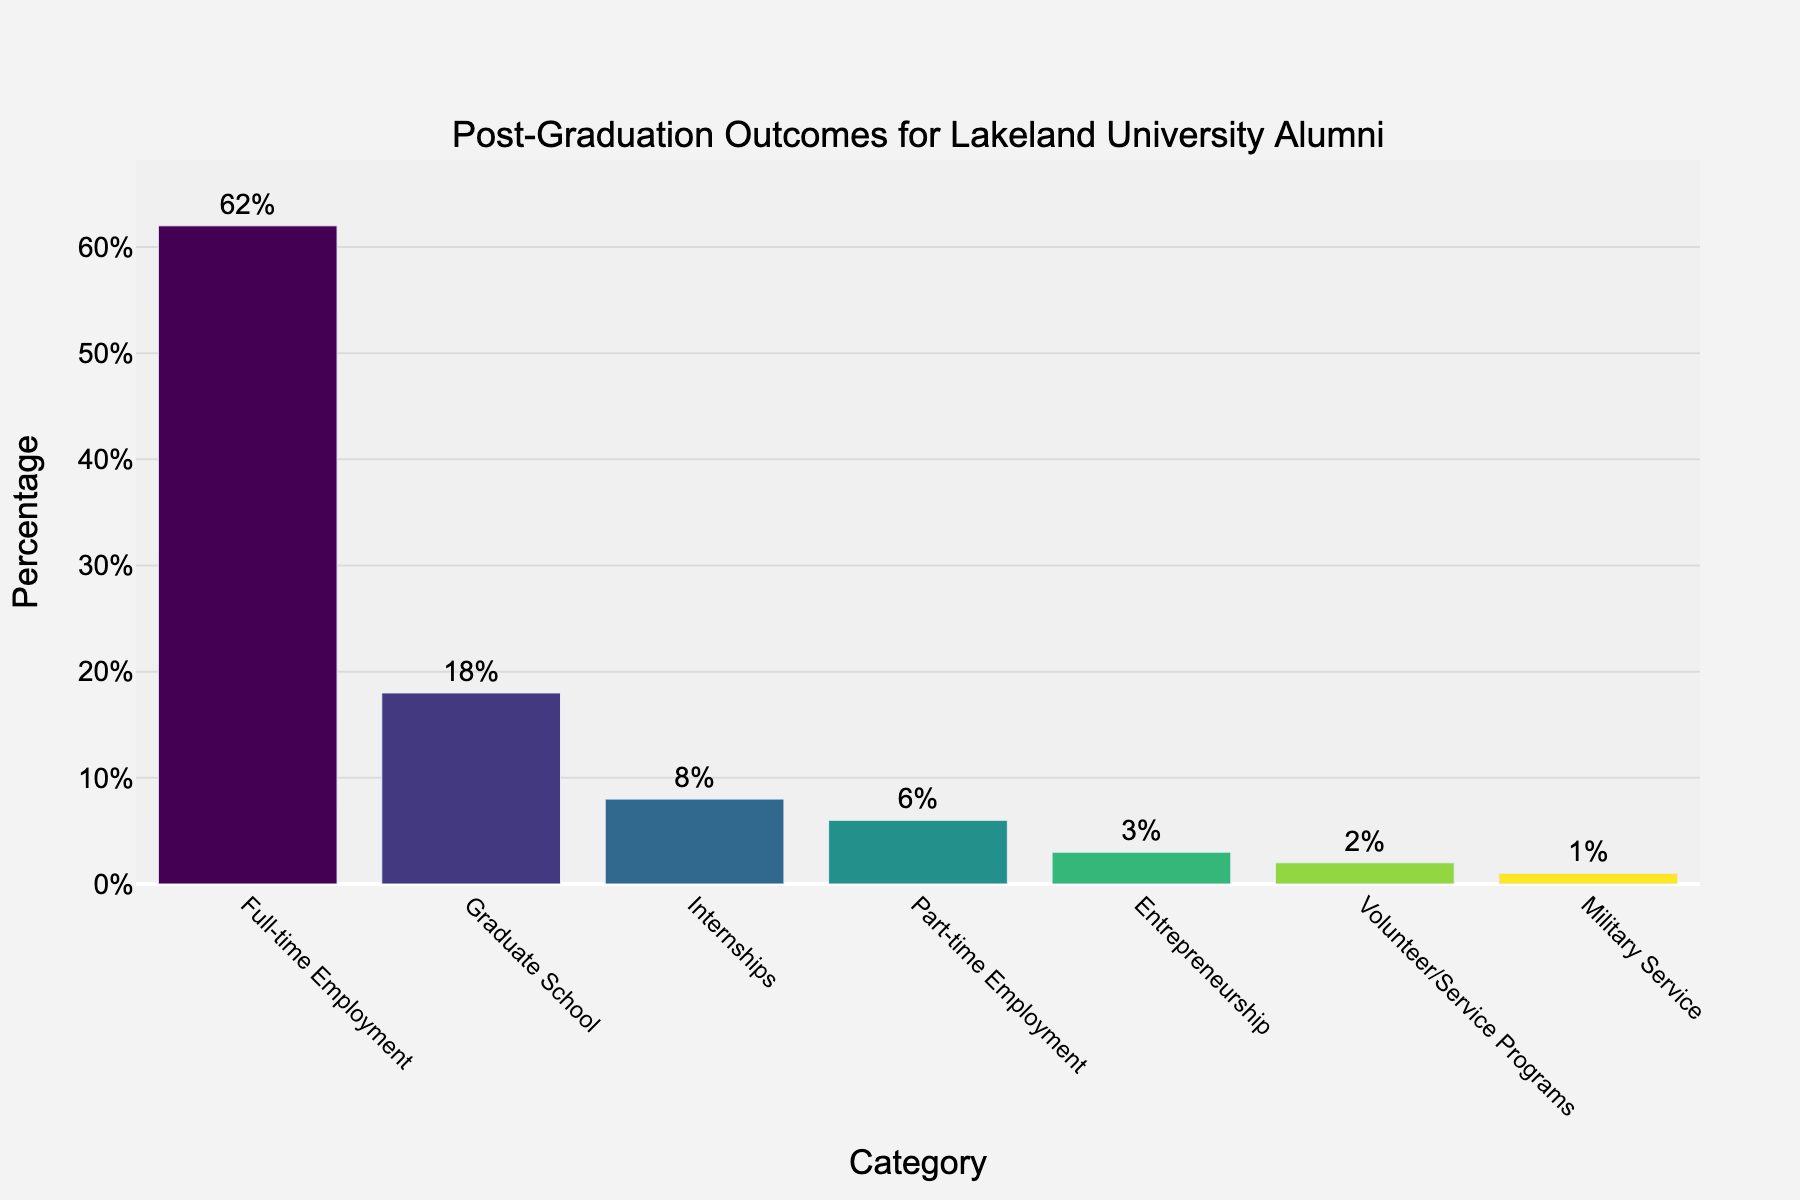Which category has the highest percentage of post-graduation outcomes? The bar representing "Full-time Employment" is the tallest and has a value of 62%.
Answer: Full-time Employment How many categories have a percentage less than 10%? "Internships" (8%), "Part-time Employment" (6%), "Entrepreneurship" (3%), "Volunteer/Service Programs" (2%), and "Military Service" (1%) all have values less than 10%. There are 5 such categories.
Answer: 5 What is the total percentage of alumni who are either in Graduate School or engaged in Full-time Employment? The percentage for "Graduate School" is 18% and for "Full-time Employment" is 62%. Adding them gives 18% + 62% = 80%.
Answer: 80% Which category has a percentage that is equal to half of the percentage of those in Graduate School? Half of 18% (Graduate School) is 9%. "Internships" has a percentage closest to this value but actual half would be 9%, whereas "Internships" is 8%.
Answer: Internships Is the percentage of alumni in Volunteer/Service Programs greater than those in Military Service? "Volunteer/Service Programs" has 2% and "Military Service" has 1%. Comparing 2% > 1% confirms this.
Answer: Yes What is the difference in percentage between Part-time Employment and Entrepreneurship? The percentage for "Part-time Employment" is 6% and for "Entrepreneurship" is 3%. The difference is 6% - 3% = 3%.
Answer: 3% What's the visual relationship between the bars for "Graduate School" and "Internships"? The bar for "Graduate School" is noticeably taller than the bar for "Internships" with "Graduate School" being at 18% and "Internships" at 8%.
Answer: Graduate School's bar is taller If you combine the percentages for Part-time Employment, Volunteer/Service Programs, and Military Service, what total does that give? The percentages are Part-time Employment (6%), Volunteer/Service Programs (2%), and Military Service (1%). Adding them gives 6% + 2% + 1% = 9%.
Answer: 9% Which two categories have the smallest percentages? "Volunteer/Service Programs" has 2%, and "Military Service" has 1%. These are the categories with the smallest percentages.
Answer: Volunteer/Service Programs and Military Service 